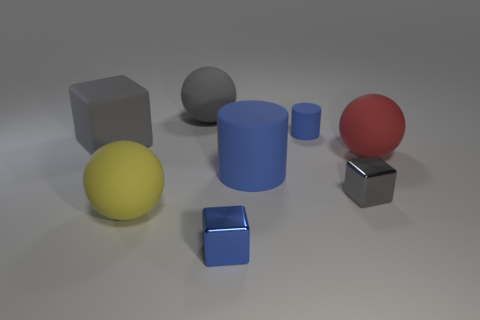What could be the purpose of arranging these objects like this? This arrangement of objects could serve several purposes. It may be a visual composition created for an art piece, a setup for a 3D rendering tutorial, or a scene designed to study lighting and shadows in photography or computer graphics. The different shapes and materials can help highlight how surfaces interact with light and shadow differently. 